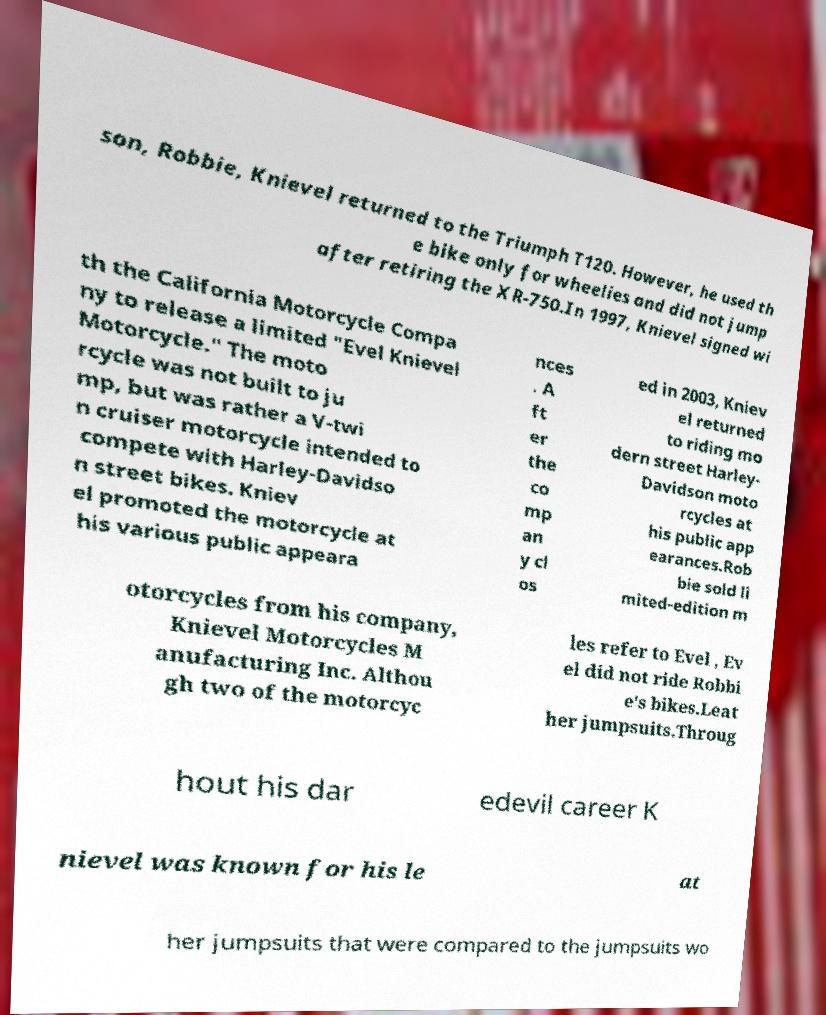I need the written content from this picture converted into text. Can you do that? son, Robbie, Knievel returned to the Triumph T120. However, he used th e bike only for wheelies and did not jump after retiring the XR-750.In 1997, Knievel signed wi th the California Motorcycle Compa ny to release a limited "Evel Knievel Motorcycle." The moto rcycle was not built to ju mp, but was rather a V-twi n cruiser motorcycle intended to compete with Harley-Davidso n street bikes. Kniev el promoted the motorcycle at his various public appeara nces . A ft er the co mp an y cl os ed in 2003, Kniev el returned to riding mo dern street Harley- Davidson moto rcycles at his public app earances.Rob bie sold li mited-edition m otorcycles from his company, Knievel Motorcycles M anufacturing Inc. Althou gh two of the motorcyc les refer to Evel , Ev el did not ride Robbi e's bikes.Leat her jumpsuits.Throug hout his dar edevil career K nievel was known for his le at her jumpsuits that were compared to the jumpsuits wo 